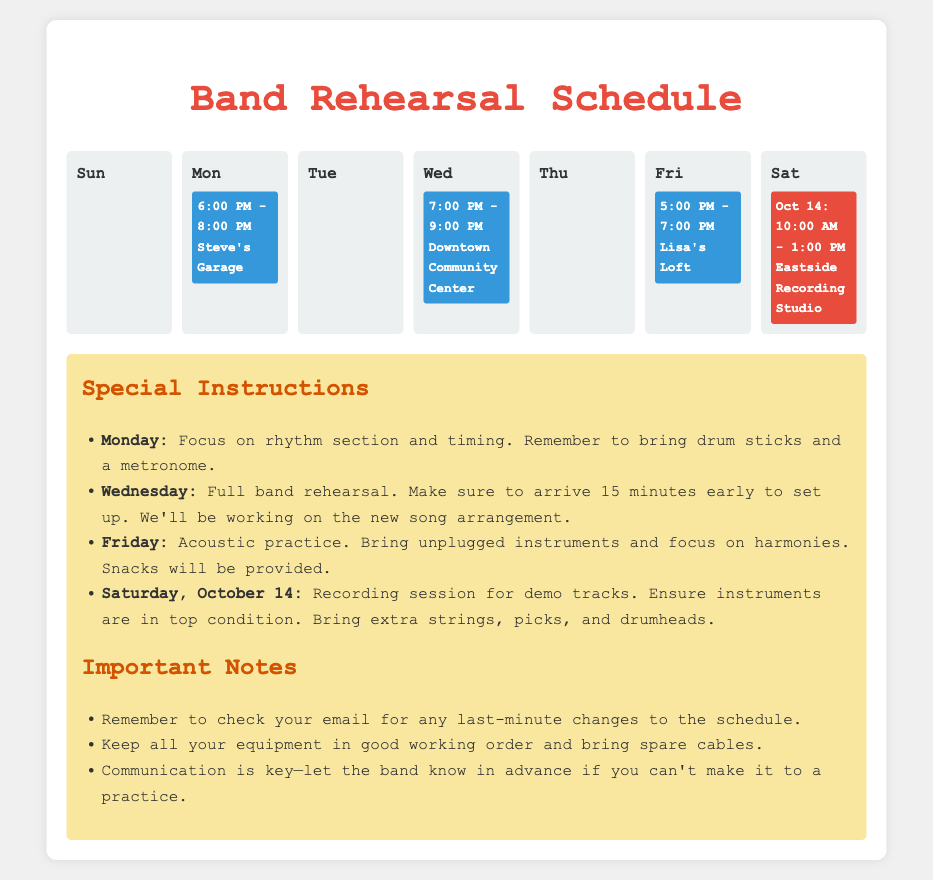What day and time is the Monday rehearsal? The Monday rehearsal is scheduled for 6:00 PM to 8:00 PM.
Answer: 6:00 PM - 8:00 PM Where is the Wednesday rehearsal held? The document states that the Wednesday rehearsal takes place at the Downtown Community Center.
Answer: Downtown Community Center What special instructions are given for Friday's rehearsal? The instructions specify to bring unplugged instruments and focus on harmonies during Friday's acoustic practice.
Answer: Bring unplugged instruments and focus on harmonies On which date does the recording session take place? The recording session is scheduled for October 14.
Answer: October 14 How many rehearsals occur during the week? The document indicates that there are four rehearsals listed for the week.
Answer: Four What should members remember to do before the full band rehearsal on Wednesday? Members are instructed to arrive 15 minutes early to set up for the Wednesday rehearsal.
Answer: Arrive 15 minutes early to set up What type of practice is held on Friday? The Friday practice is described as an acoustic practice.
Answer: Acoustic practice What is the main focus of the Monday rehearsal? The focus for Monday is on the rhythm section and timing.
Answer: Rhythm section and timing 